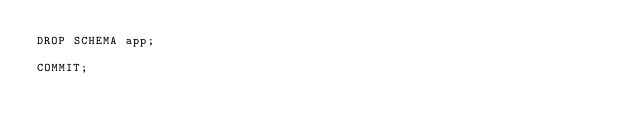Convert code to text. <code><loc_0><loc_0><loc_500><loc_500><_SQL_>DROP SCHEMA app;

COMMIT;
</code> 